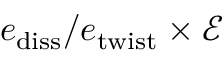Convert formula to latex. <formula><loc_0><loc_0><loc_500><loc_500>e _ { d i s s } / e _ { t w i s t } \times \mathcal { E }</formula> 